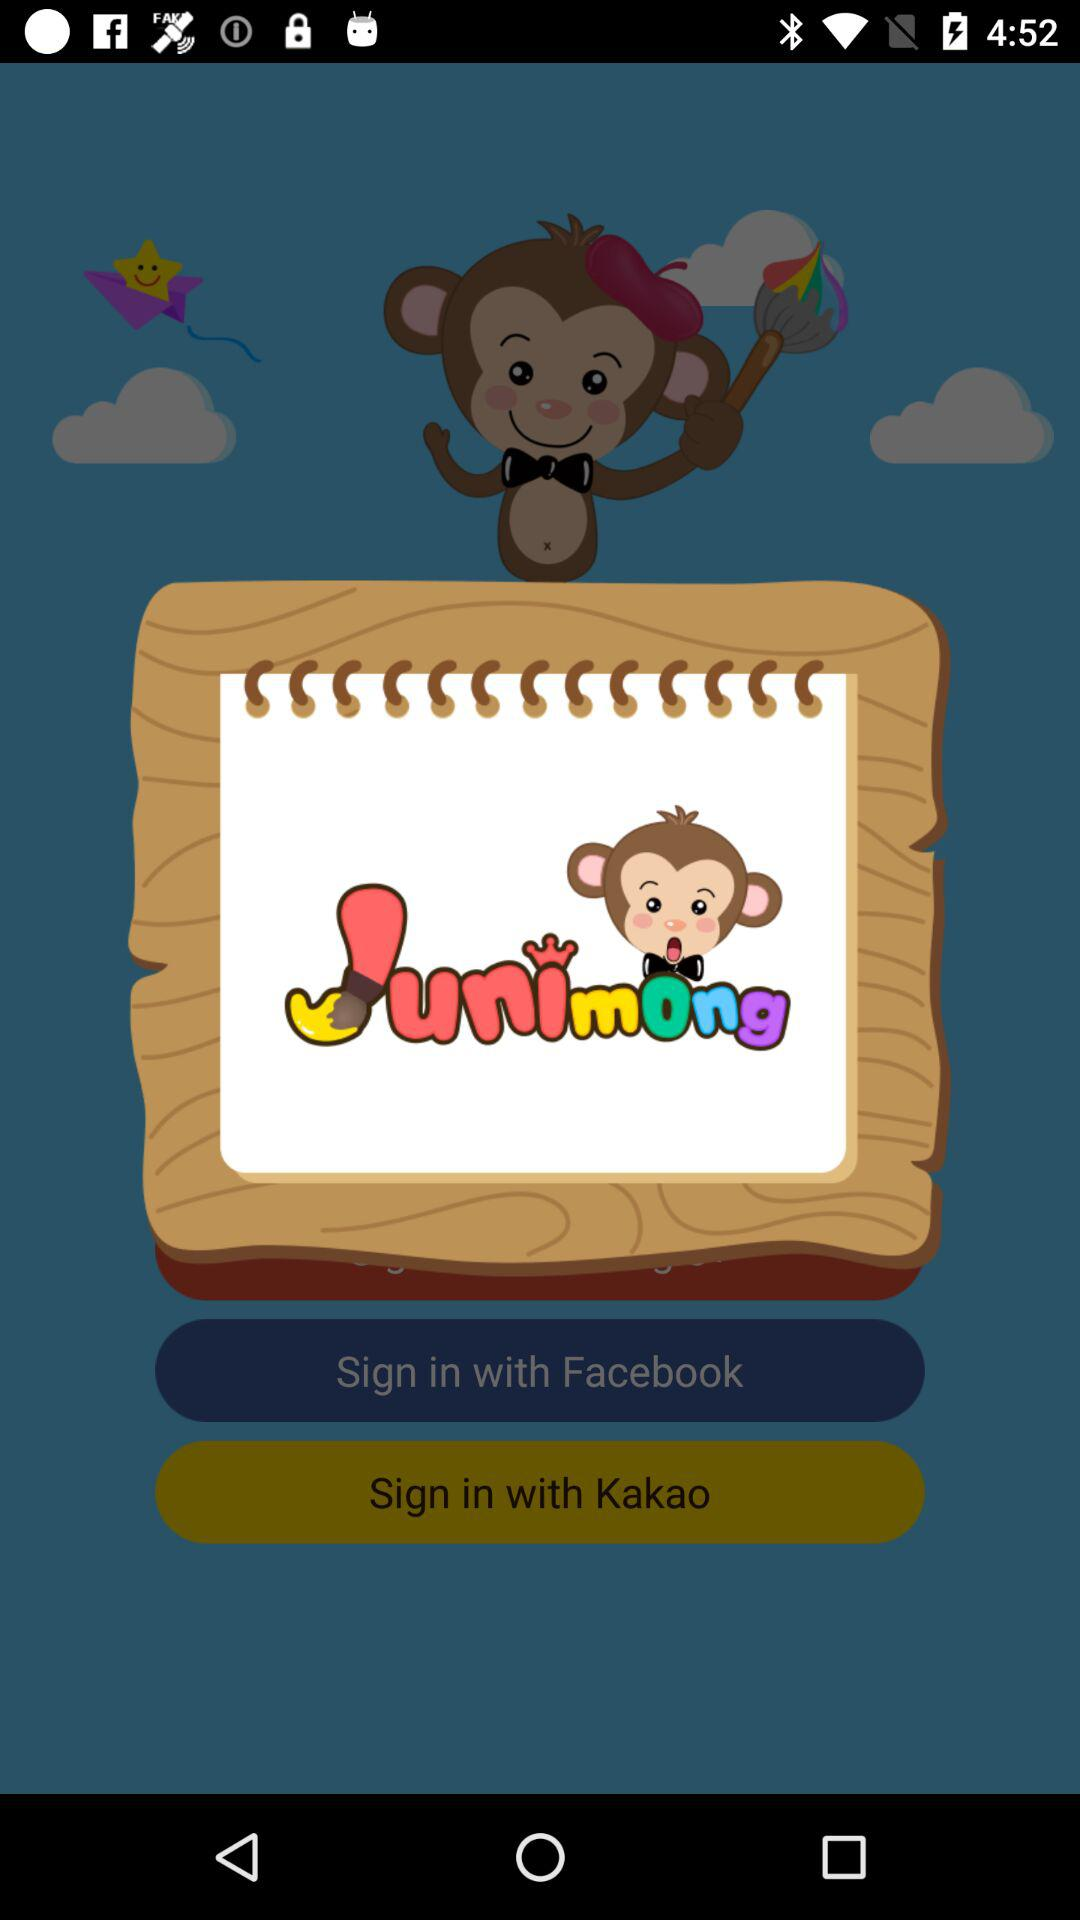How long does it take to sign in with an account?
When the provided information is insufficient, respond with <no answer>. <no answer> 